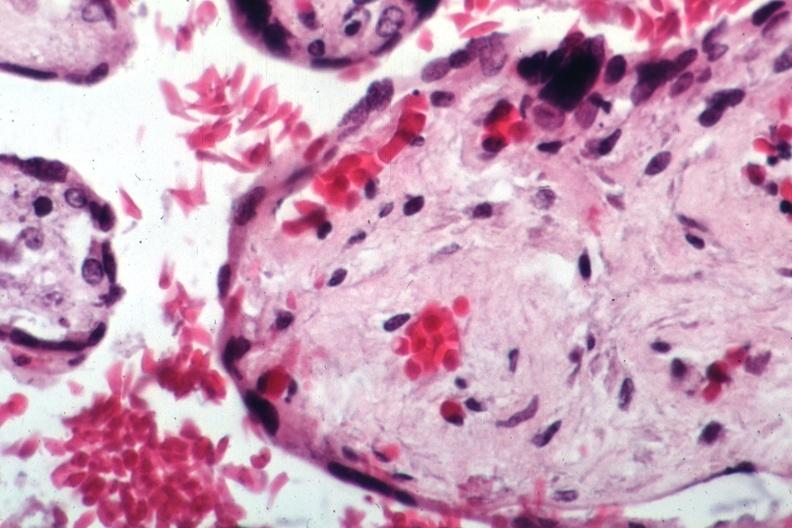does this image show sickled maternal cells readily evident?
Answer the question using a single word or phrase. Yes 